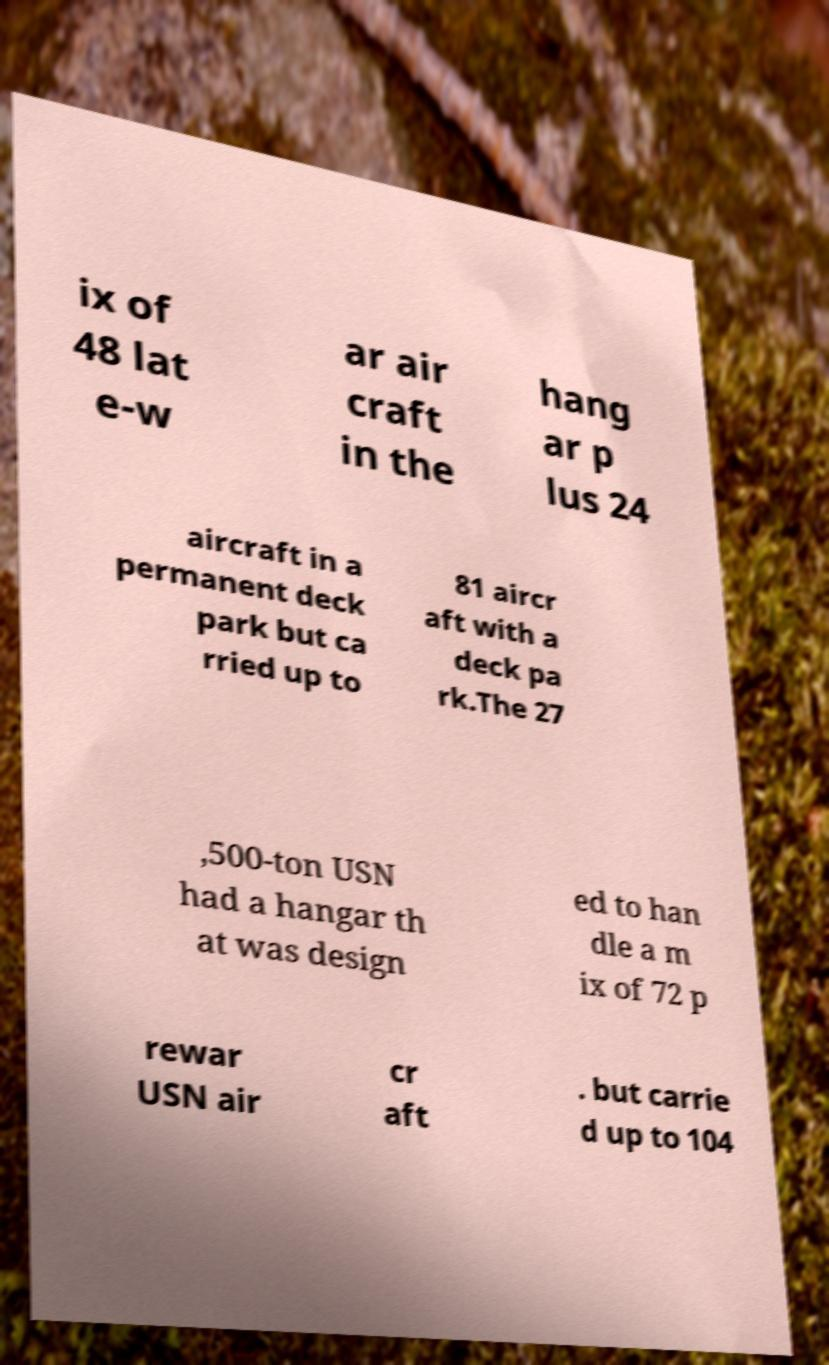Could you extract and type out the text from this image? ix of 48 lat e-w ar air craft in the hang ar p lus 24 aircraft in a permanent deck park but ca rried up to 81 aircr aft with a deck pa rk.The 27 ,500-ton USN had a hangar th at was design ed to han dle a m ix of 72 p rewar USN air cr aft . but carrie d up to 104 